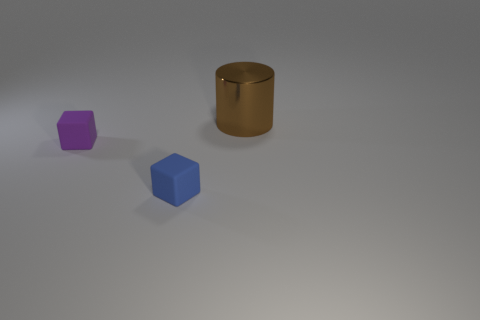Add 2 metallic cylinders. How many objects exist? 5 Subtract all cylinders. How many objects are left? 2 Subtract 0 gray spheres. How many objects are left? 3 Subtract all brown metal cylinders. Subtract all tiny matte things. How many objects are left? 0 Add 2 blue cubes. How many blue cubes are left? 3 Add 1 tiny cyan metallic objects. How many tiny cyan metallic objects exist? 1 